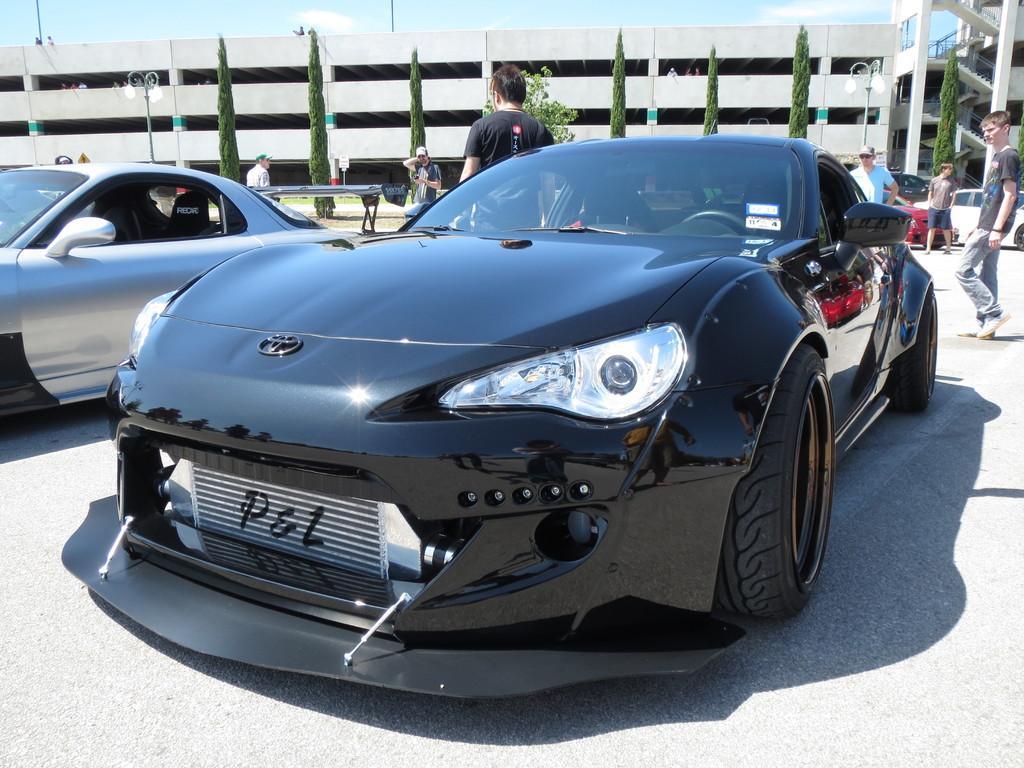Could you give a brief overview of what you see in this image? This picture consists of two vehicles the foreground , in the background there is a building, trees and vehicles visible in front of the building on the right side and some persons visible in the middle, at the topic and see the sky and poles visible in front of the building. 